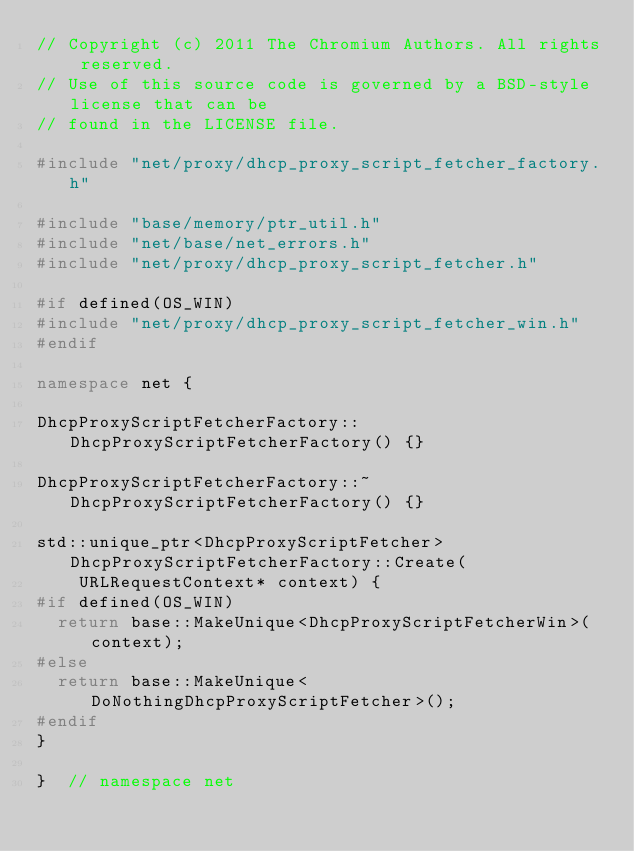<code> <loc_0><loc_0><loc_500><loc_500><_C++_>// Copyright (c) 2011 The Chromium Authors. All rights reserved.
// Use of this source code is governed by a BSD-style license that can be
// found in the LICENSE file.

#include "net/proxy/dhcp_proxy_script_fetcher_factory.h"

#include "base/memory/ptr_util.h"
#include "net/base/net_errors.h"
#include "net/proxy/dhcp_proxy_script_fetcher.h"

#if defined(OS_WIN)
#include "net/proxy/dhcp_proxy_script_fetcher_win.h"
#endif

namespace net {

DhcpProxyScriptFetcherFactory::DhcpProxyScriptFetcherFactory() {}

DhcpProxyScriptFetcherFactory::~DhcpProxyScriptFetcherFactory() {}

std::unique_ptr<DhcpProxyScriptFetcher> DhcpProxyScriptFetcherFactory::Create(
    URLRequestContext* context) {
#if defined(OS_WIN)
  return base::MakeUnique<DhcpProxyScriptFetcherWin>(context);
#else
  return base::MakeUnique<DoNothingDhcpProxyScriptFetcher>();
#endif
}

}  // namespace net
</code> 